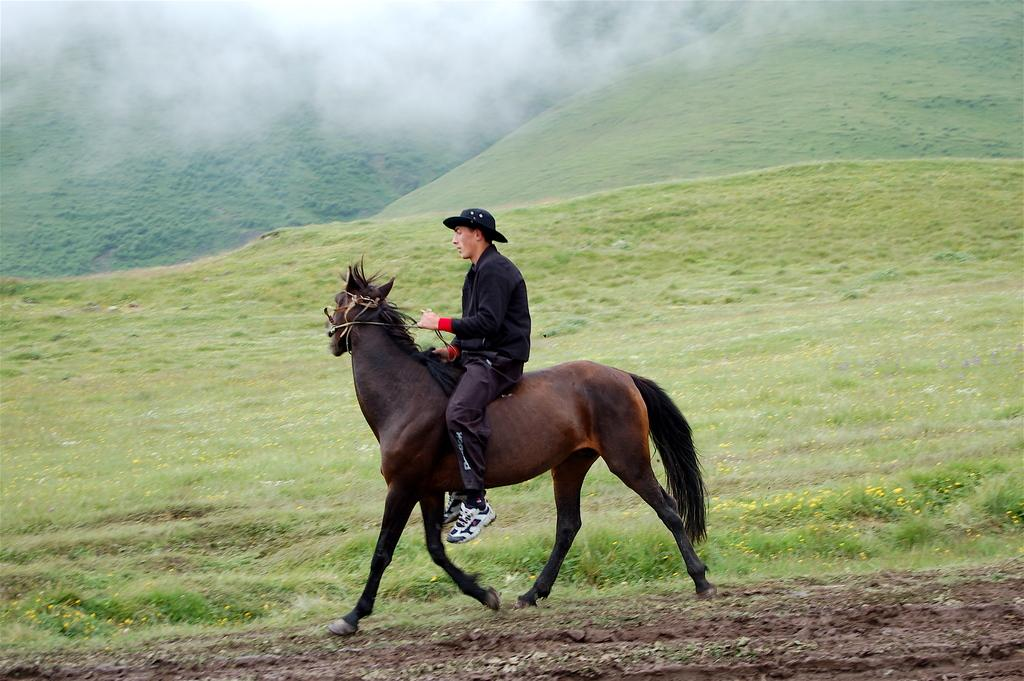What is the main subject of the image? There is a person in the image. What is the person doing in the image? The person is sitting on a horse and riding it. What can be seen in the background of the image? There are mountains and fog in the background of the image. What type of terrain is visible at the bottom of the image? There is grass and sand at the bottom of the image. How many railway tracks can be seen in the image? There are no railway tracks present in the image. What type of attraction is the person visiting in the image? There is no indication of an attraction in the image; it simply shows a person riding a horse. 